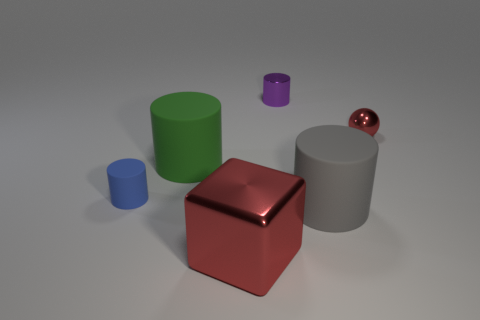Add 3 small shiny balls. How many objects exist? 9 Subtract all shiny cylinders. How many cylinders are left? 3 Subtract all blocks. How many objects are left? 5 Add 5 big cyan matte spheres. How many big cyan matte spheres exist? 5 Subtract all gray cylinders. How many cylinders are left? 3 Subtract 0 brown cylinders. How many objects are left? 6 Subtract 1 cubes. How many cubes are left? 0 Subtract all cyan balls. Subtract all green cylinders. How many balls are left? 1 Subtract all tiny gray shiny objects. Subtract all balls. How many objects are left? 5 Add 2 small shiny balls. How many small shiny balls are left? 3 